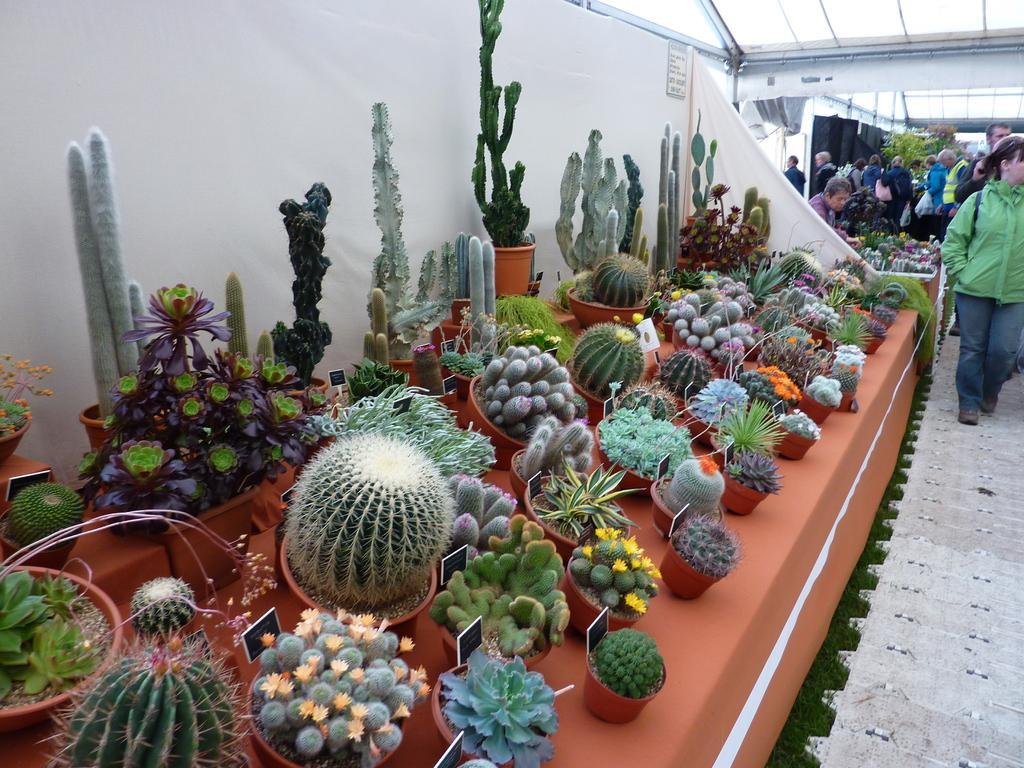Can you describe this image briefly? In this image there is a table on which there are cactus plants one beside the other. It seems like a market. On the right side there are few people walking on the floor, while some people are standing near the plants. At the top there is ceiling. 